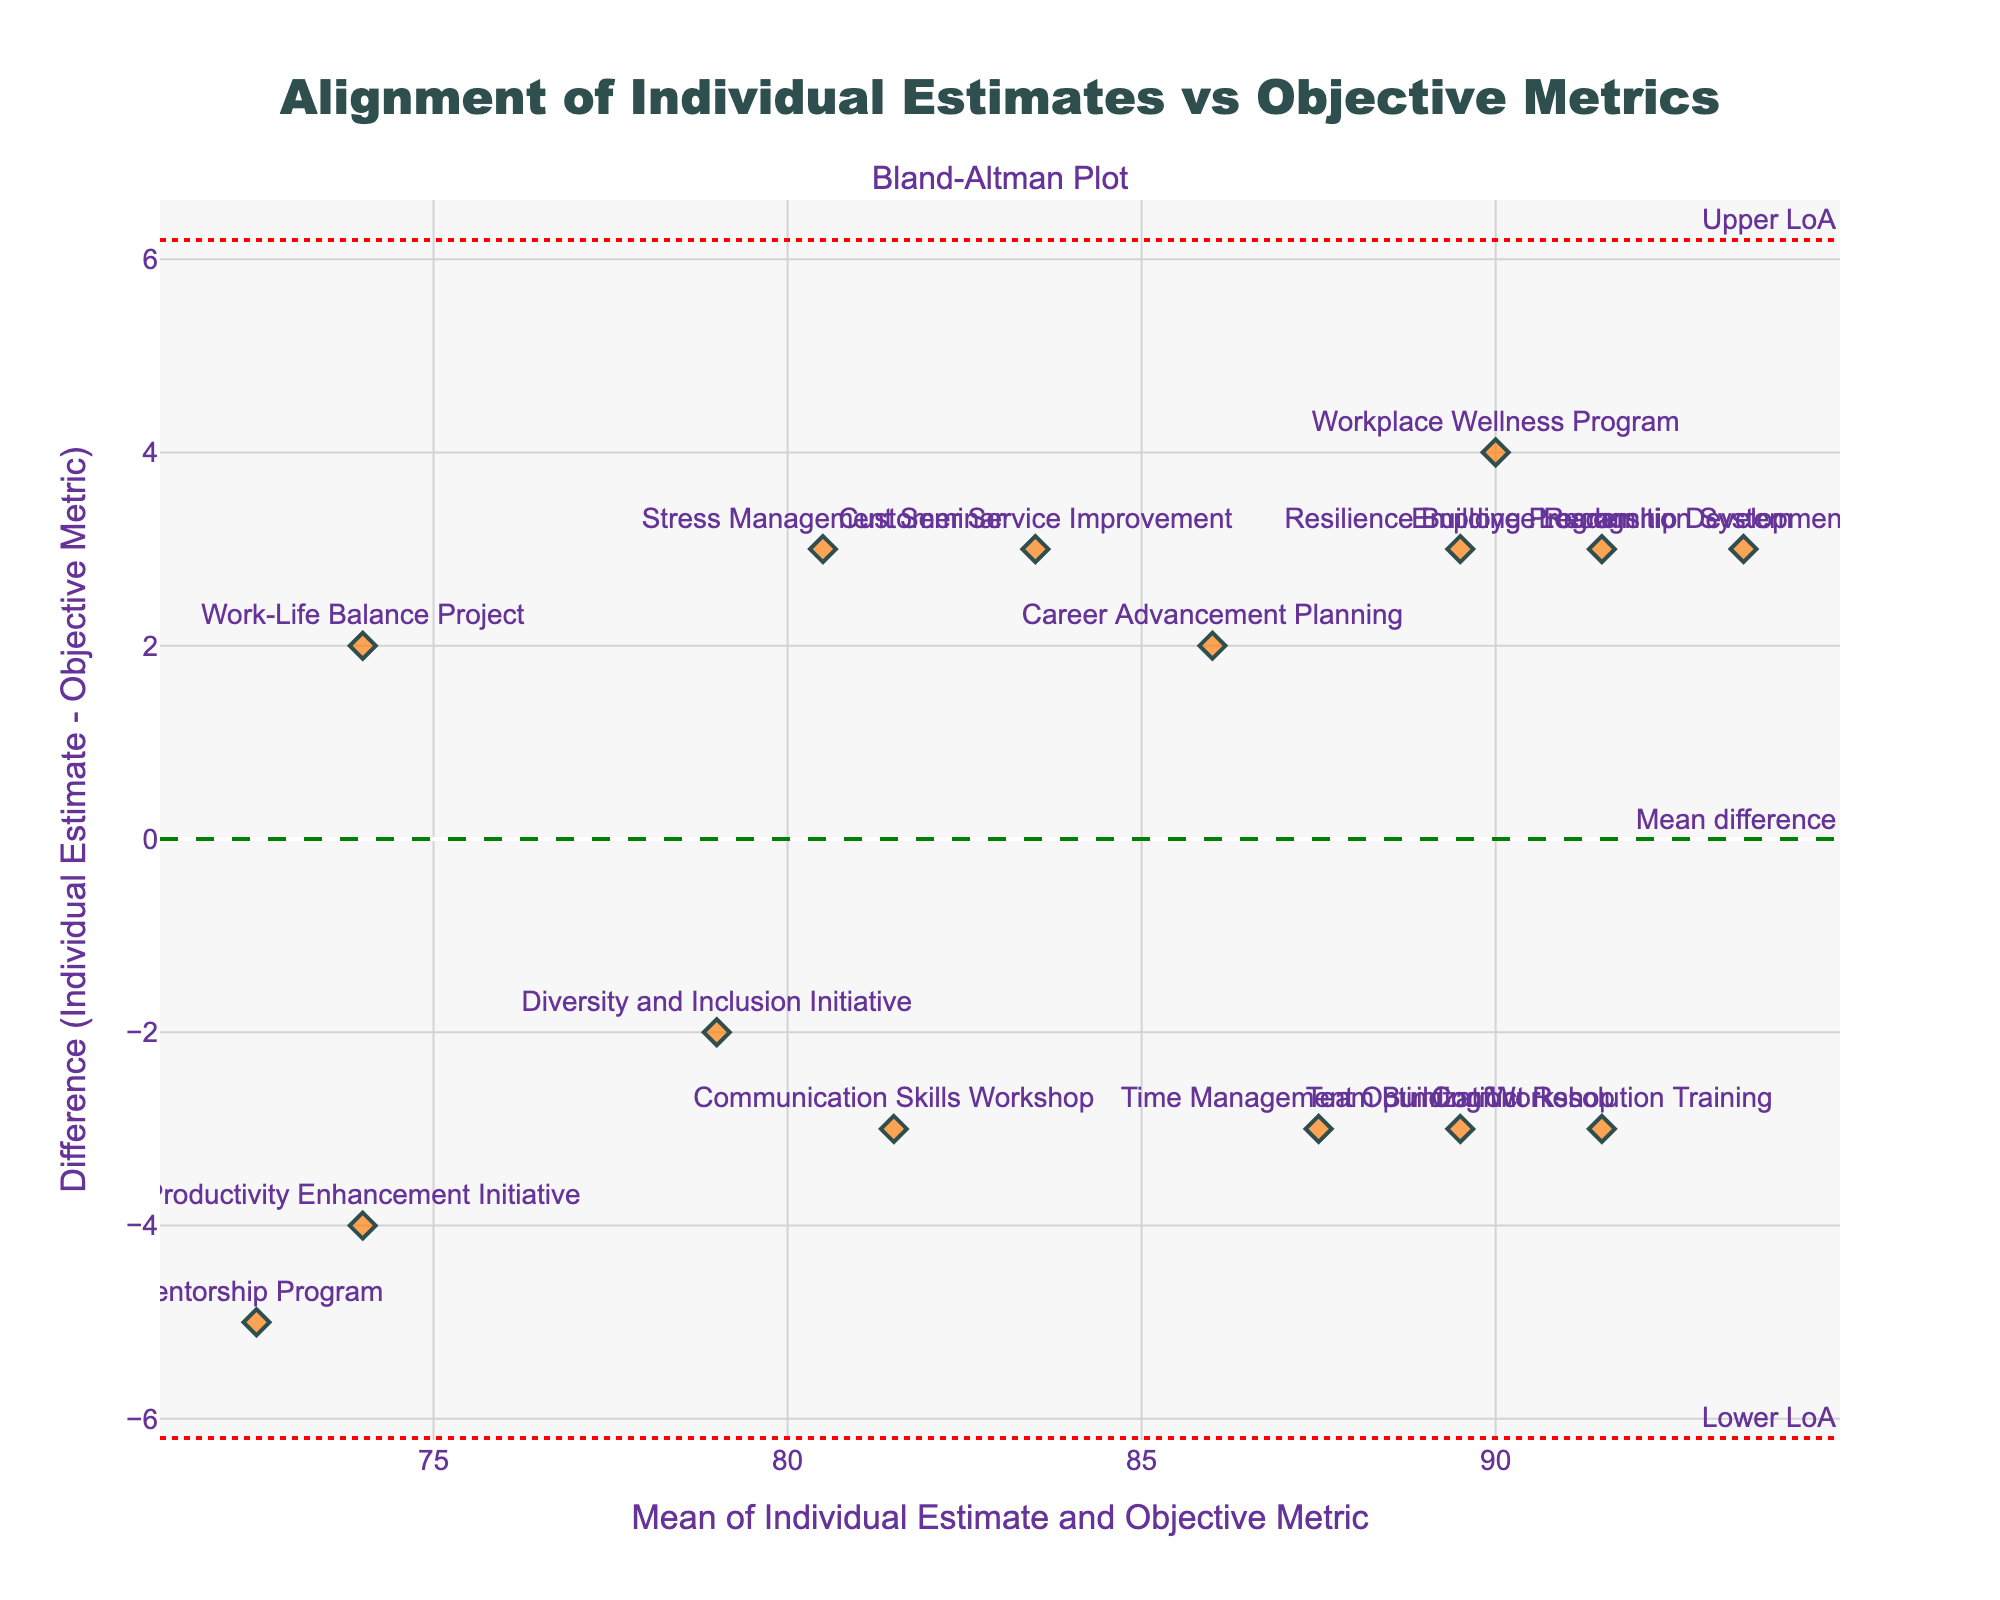what is the title of the figure? The title is located at the top of the figure and is meant to provide a brief summary of the chart's purpose.
Answer: Alignment of Individual Estimates vs Objective Metrics what do the x-axis and y-axis represent? The x-axis represents the mean of individual estimate and objective metric, while the y-axis shows the difference between individual estimate and objective metric.
Answer: x-axis: Mean of Individual Estimate and Objective Metric; y-axis: Difference (Individual Estimate - Objective Metric) how many data points are there in the plot? Each point in the plot represents a specific project, so counting the number of points will give the total number of data points.
Answer: 15 what is the mean difference line's annotation color? The mean difference line is annotated with a specific color for distinction. By searching visually for the dashed line with annotation text ‘Mean difference’, the color can be determined.
Answer: green which project has the highest positive difference between individual estimate and objective metric? To find this, identify the data point farthest above the zero line on the y-axis and check its label.
Answer: Leadership Development Course what are the values of the upper and lower limits of agreement? The upper limit is represented by the upper horizontal dotted red line, and the lower limit by the lower horizontal dotted red line. These lines have their values annotated next to the corresponding positions.
Answer: Upper LoA: 8.71, Lower LoA: -8.31 which project is closest to the mean difference line? Identify the data point closest to the mean difference line (dashed green line). Refer its label to determine which project it represents.
Answer: Stress Management Seminar is there any project whose individual estimate is exactly equal to the objective metric? If there is a project with no difference between the individual estimate and the objective metric, its data point would lie exactly on the y=0 line. Checking these points will give the answer.
Answer: None which two projects have the closest mean values around 80? Identify the mean values close to 80 on the x-axis, look for clusters of points in this area, and verify which projects they represent.
Answer: Stress Management Seminar, Communication Skills Workshop 